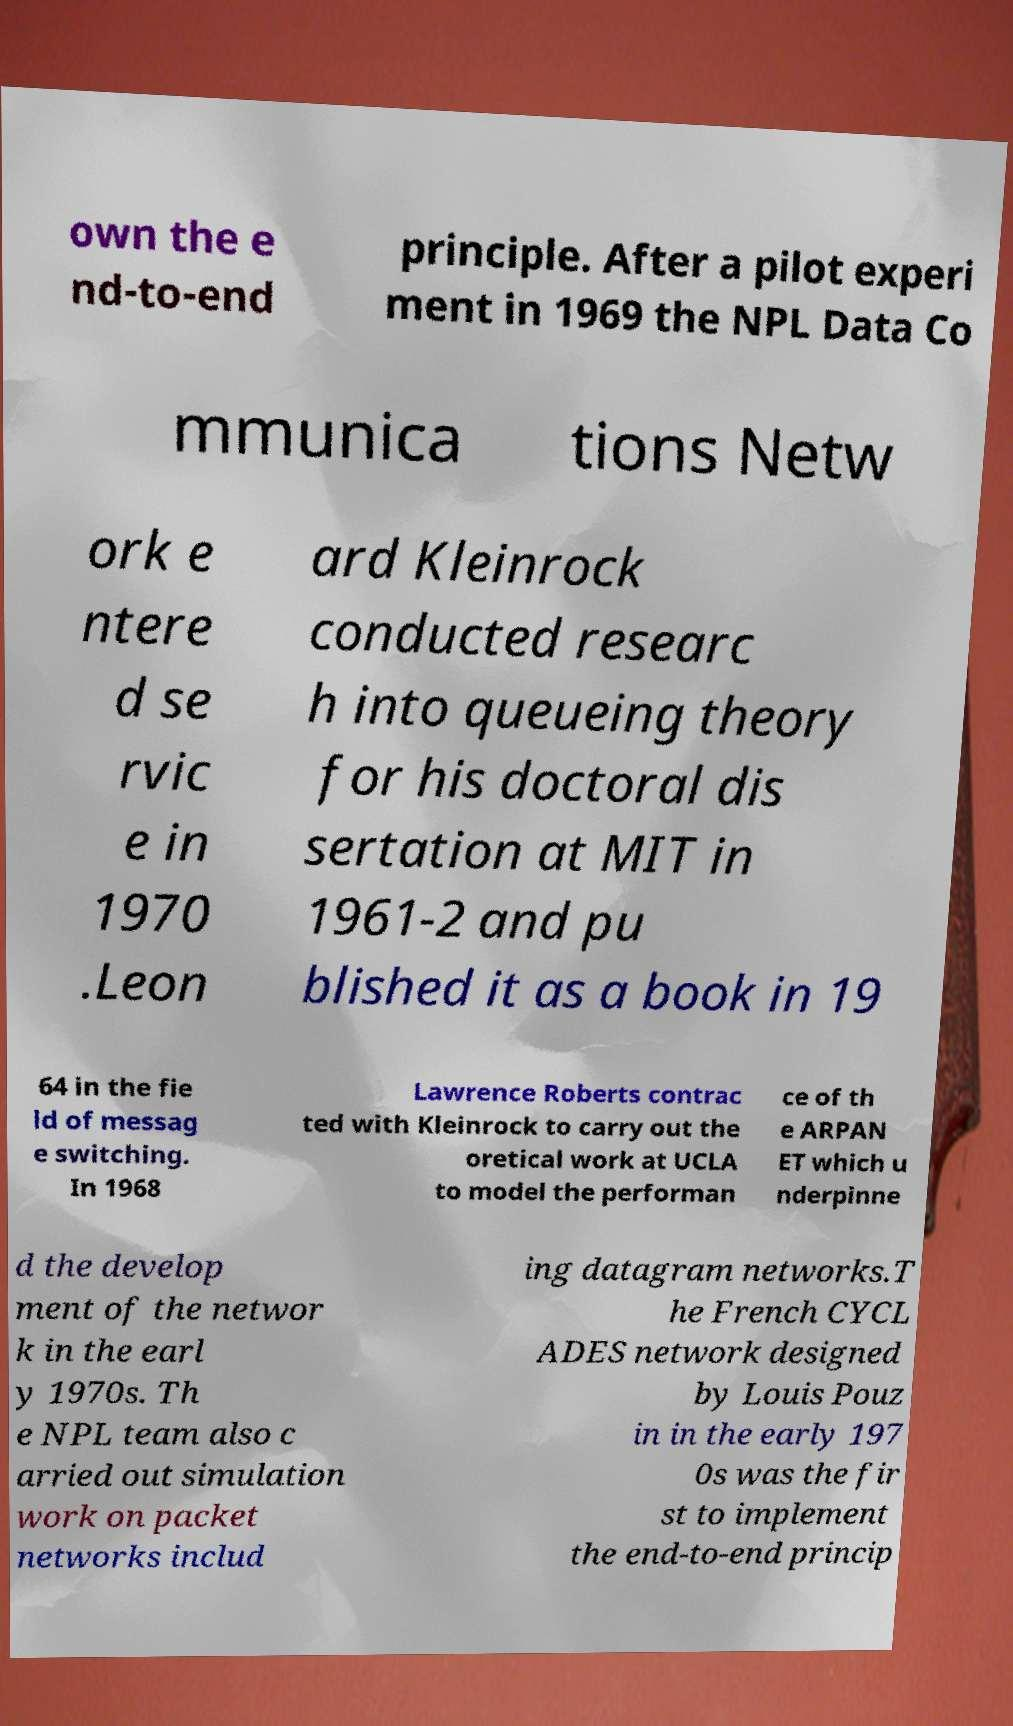There's text embedded in this image that I need extracted. Can you transcribe it verbatim? own the e nd-to-end principle. After a pilot experi ment in 1969 the NPL Data Co mmunica tions Netw ork e ntere d se rvic e in 1970 .Leon ard Kleinrock conducted researc h into queueing theory for his doctoral dis sertation at MIT in 1961-2 and pu blished it as a book in 19 64 in the fie ld of messag e switching. In 1968 Lawrence Roberts contrac ted with Kleinrock to carry out the oretical work at UCLA to model the performan ce of th e ARPAN ET which u nderpinne d the develop ment of the networ k in the earl y 1970s. Th e NPL team also c arried out simulation work on packet networks includ ing datagram networks.T he French CYCL ADES network designed by Louis Pouz in in the early 197 0s was the fir st to implement the end-to-end princip 